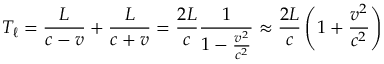Convert formula to latex. <formula><loc_0><loc_0><loc_500><loc_500>T _ { \ell } = { \frac { L } { c - v } } + { \frac { L } { c + v } } = { \frac { 2 L } { c } } { \frac { 1 } { 1 - { \frac { v ^ { 2 } } { c ^ { 2 } } } } } \approx { \frac { 2 L } { c } } \left ( 1 + { \frac { v ^ { 2 } } { c ^ { 2 } } } \right )</formula> 